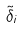Convert formula to latex. <formula><loc_0><loc_0><loc_500><loc_500>\tilde { \delta } _ { i }</formula> 